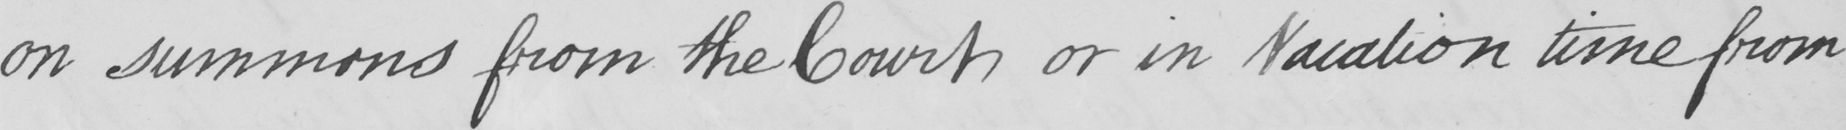Can you tell me what this handwritten text says? on summons from the Court , or in Vacation time from 